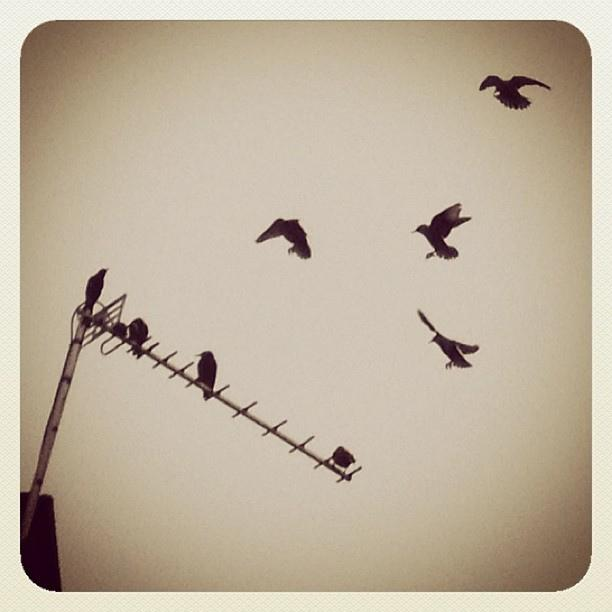Why do the birds seek high up places? safety 